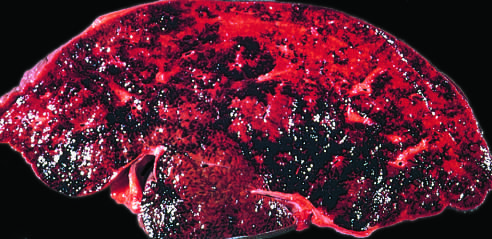has thrombosis of the major hepatic veins caused severe hepatic congestion?
Answer the question using a single word or phrase. Yes 